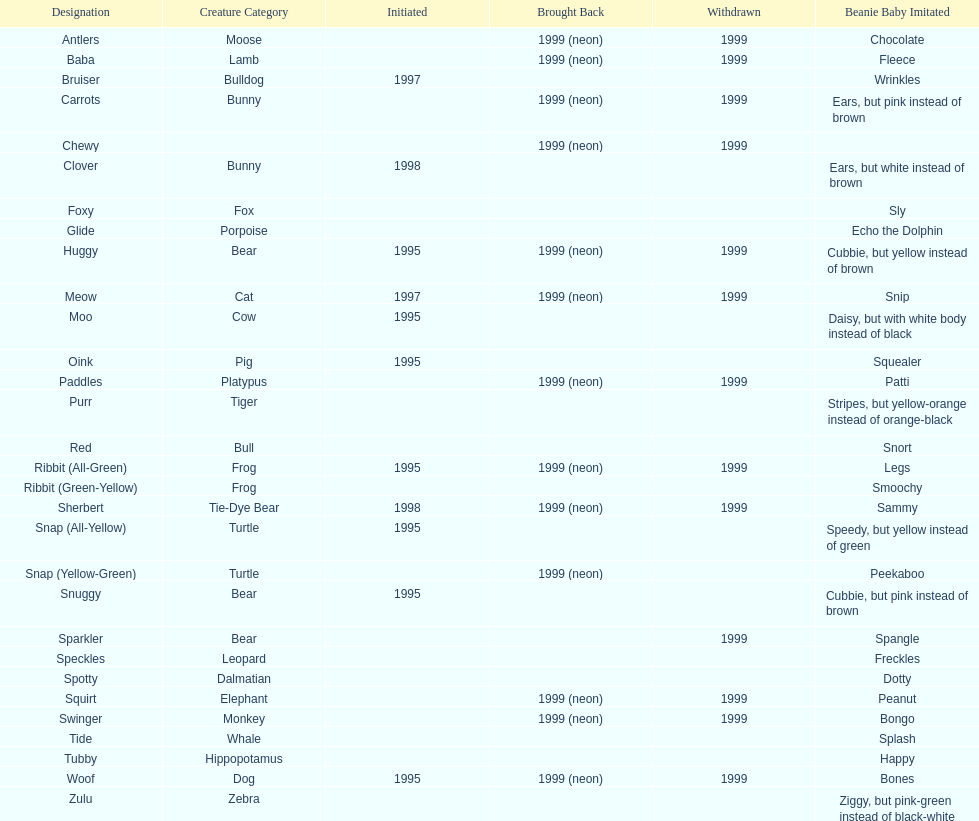In what year were the first pillow pals introduced? 1995. 